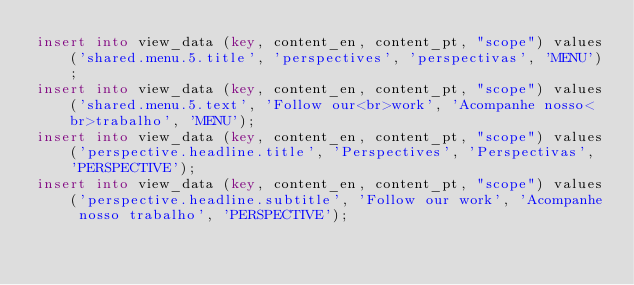Convert code to text. <code><loc_0><loc_0><loc_500><loc_500><_SQL_>insert into view_data (key, content_en, content_pt, "scope") values('shared.menu.5.title', 'perspectives', 'perspectivas', 'MENU');
insert into view_data (key, content_en, content_pt, "scope") values('shared.menu.5.text', 'Follow our<br>work', 'Acompanhe nosso<br>trabalho', 'MENU');
insert into view_data (key, content_en, content_pt, "scope") values('perspective.headline.title', 'Perspectives', 'Perspectivas', 'PERSPECTIVE');
insert into view_data (key, content_en, content_pt, "scope") values('perspective.headline.subtitle', 'Follow our work', 'Acompanhe nosso trabalho', 'PERSPECTIVE');</code> 